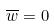Convert formula to latex. <formula><loc_0><loc_0><loc_500><loc_500>\overline { w } = 0</formula> 